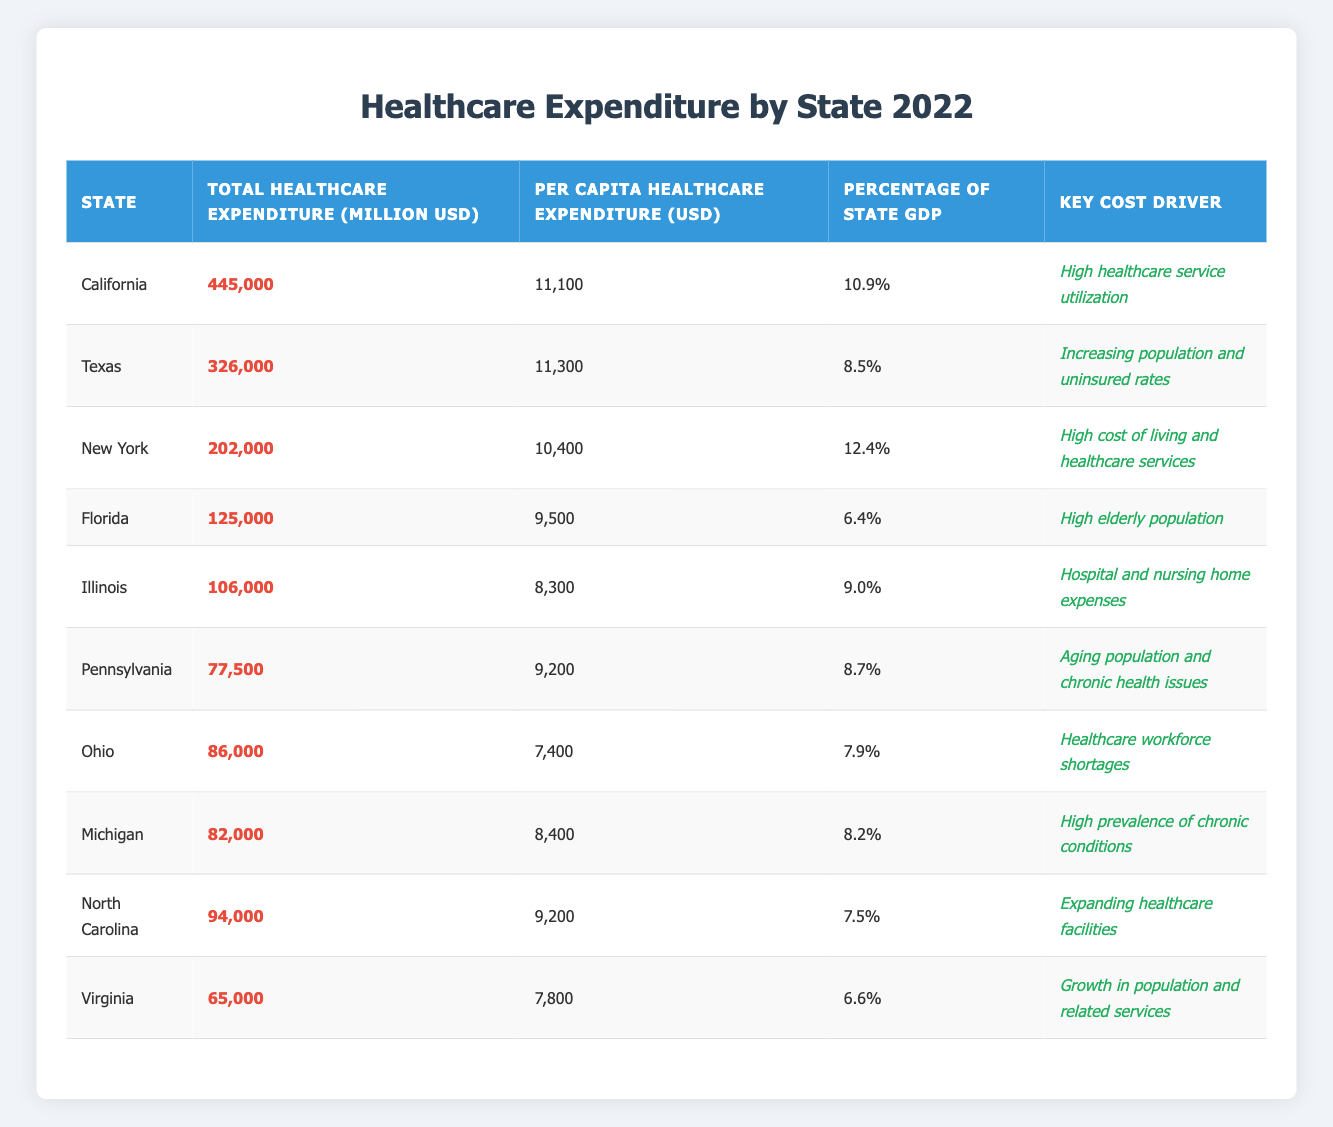What is the total healthcare expenditure for California? The table shows California's total healthcare expenditure as 445,000 million USD.
Answer: 445,000 million USD Which state has the highest per capita healthcare expenditure? Texas has the highest per capita healthcare expenditure at 11,300 USD as indicated in the table.
Answer: Texas What percentage of New York's GDP is spent on healthcare? The table indicates that New York spends 12.4% of its GDP on healthcare.
Answer: 12.4% Calculate the average total healthcare expenditure of the states listed in the table. The total healthcare expenditure values are 445,000 + 326,000 + 202,000 + 125,000 + 106,000 + 77,500 + 86,000 + 82,000 + 94,000 + 65,000 = 1,263,500 million USD. There are 10 states, so the average is 1,263,500 / 10 = 126,350 million USD.
Answer: 126,350 million USD Is Florida's per capita healthcare expenditure above the national average? Comparing Florida's per capita expenditure of 9,500 USD with the figures from other states, it appears lower than several states, indicating it may be below the national average; thus, the statement is likely false.
Answer: No Which state has the lowest total healthcare expenditure? Virginia has the lowest total healthcare expenditure at 65,000 million USD as shown in the table.
Answer: Virginia Does Pennsylvania have a higher percentage of GDP spent on healthcare than Texas? Pennsylvania spends 8.7% of its GDP on healthcare, while Texas spends 8.5%, so Pennsylvania's percentage is higher.
Answer: Yes What is the difference in total healthcare expenditure between California and Florida? The difference is calculated by subtracting Florida's expenditure (125,000 million USD) from California's (445,000 million USD), resulting in 445,000 - 125,000 = 320,000 million USD.
Answer: 320,000 million USD Which state has a key cost driver related to an aging population? Florida and Pennsylvania both have key cost drivers related to the aging population, as indicated in their respective rows in the table.
Answer: Florida and Pennsylvania Identify the state with the highest percentage of GDP spent on healthcare. The table shows that New York has the highest percentage of GDP spent on healthcare at 12.4%.
Answer: New York 